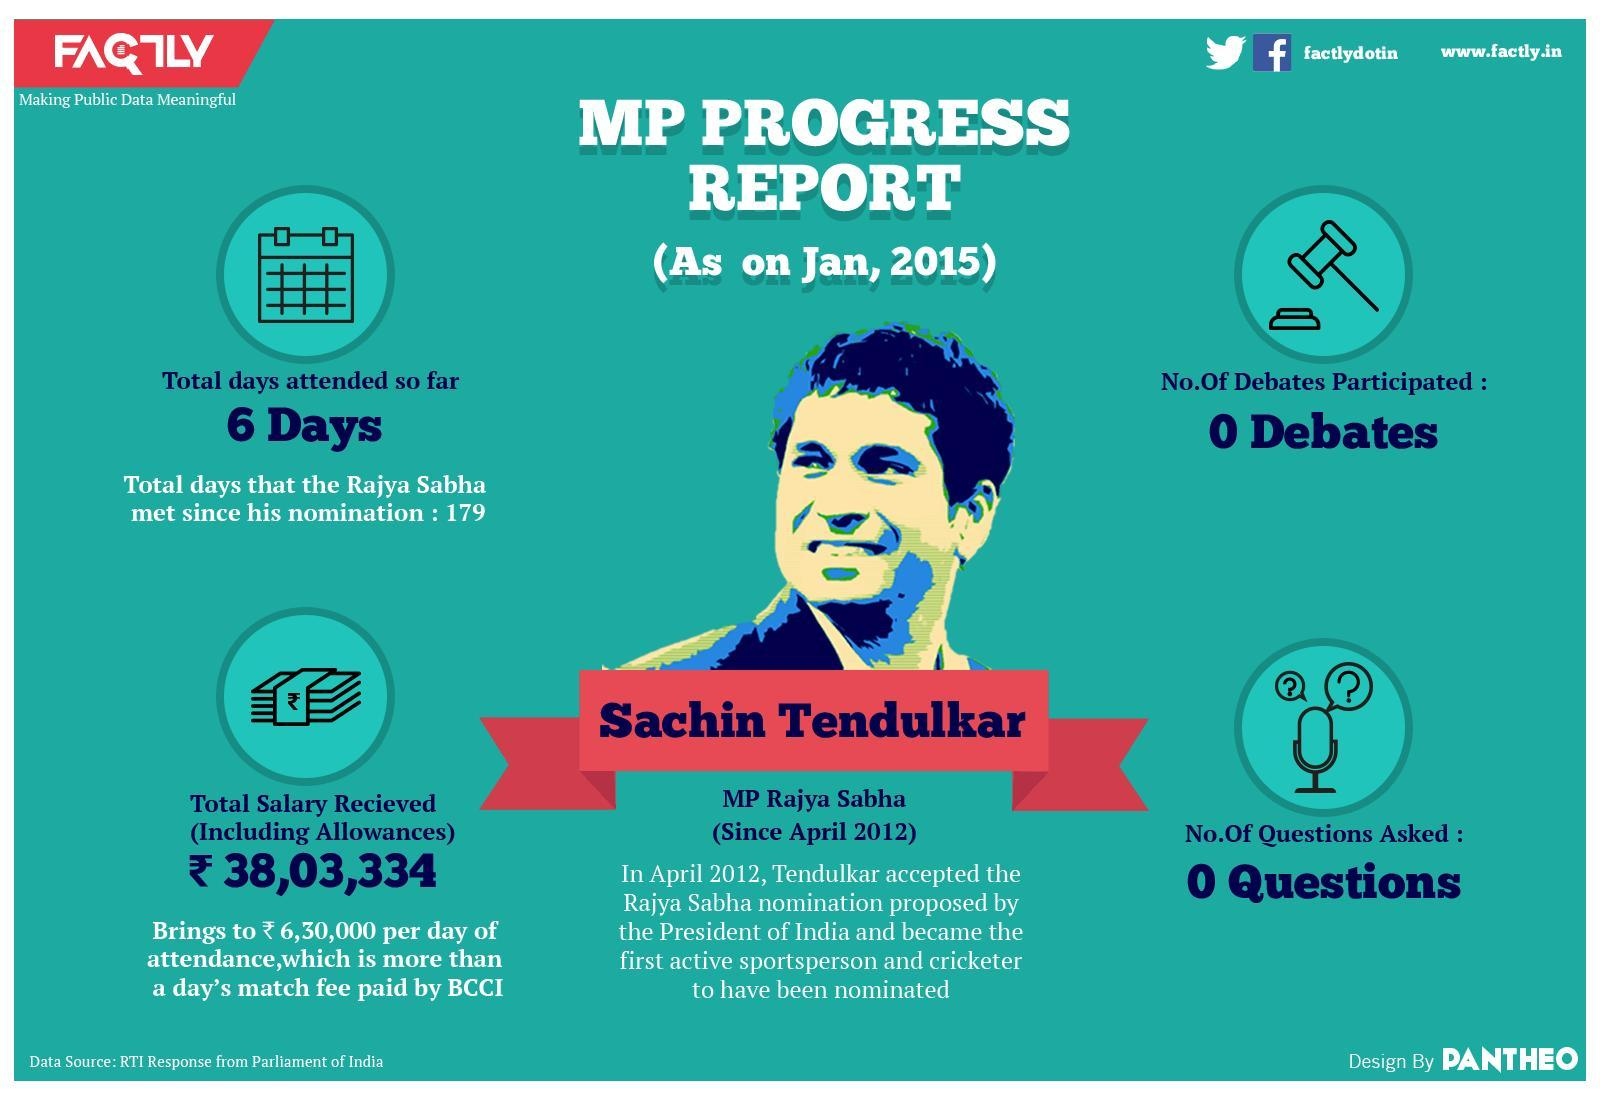How many times Rajya Sabha met without Sachin Tendulkar?
Answer the question with a short phrase. 173 What is the salary in Rupees received by MP Sachin for a day? 6,30,000 